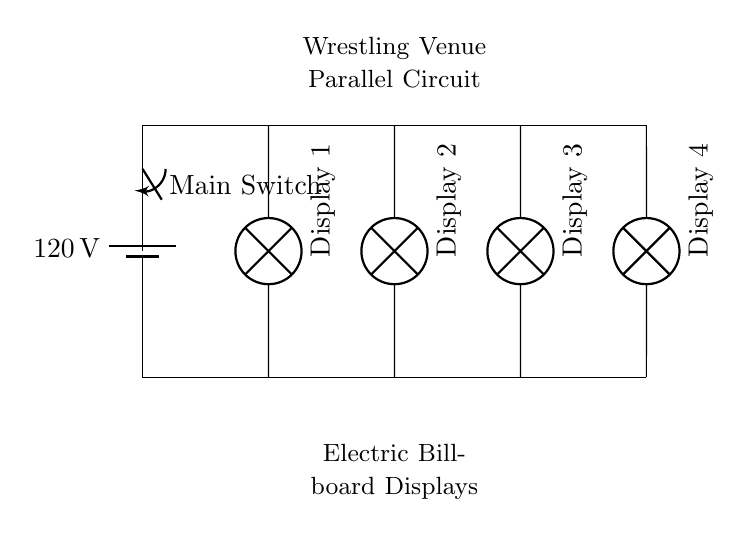What is the voltage supplied to the circuit? The voltage is indicated by the battery symbol at the top of the circuit diagram, showing a value of 120 volts.
Answer: 120 volts How many billboard displays are connected in this circuit? The diagram shows four individual lamp symbols, each representing a billboard display, labeled as Display 1, Display 2, Display 3, and Display 4.
Answer: Four What type of circuit is used to connect the billboard displays? The connection of the displays is shown in such a way that each is connected to the same two nodes (the main line and the ground), which is characteristic of a parallel circuit configuration.
Answer: Parallel What is the function of the main switch in this circuit? The main switch connects the battery to the rest of the circuit, allowing or interrupting the flow of electricity to all connected components (billboards), effectively controlling their operation.
Answer: Control What happens to other displays if one display fails? In a parallel circuit, if one display fails (like a lamp burning out), the others will continue to operate because they have separate paths for current, ensuring that the failure does not affect the entire circuit.
Answer: Others continue to operate What is the purpose of the switch placed in the circuit? The switch enables the user to turn the entire circuit on or off, allowing all displays to be activated or deactivated simultaneously, improving convenience and safety for managing the billboards.
Answer: On/Off control 